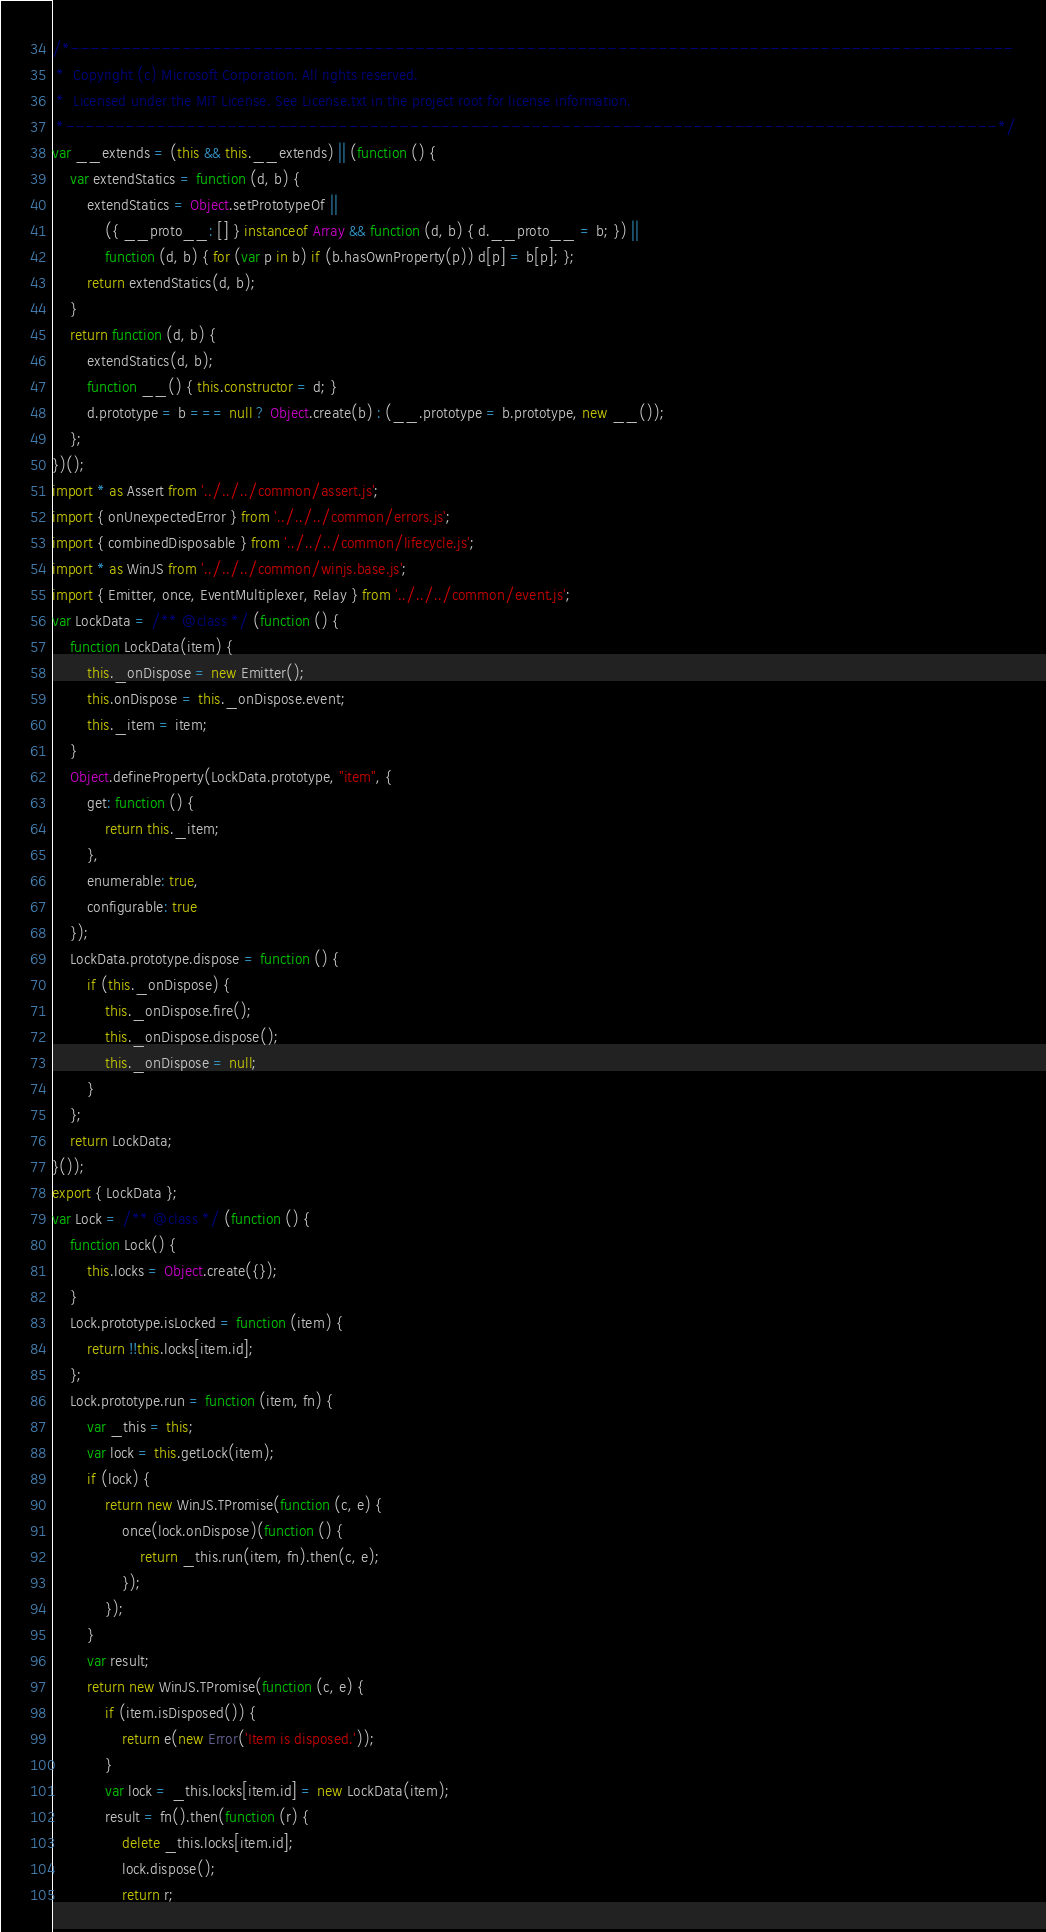<code> <loc_0><loc_0><loc_500><loc_500><_JavaScript_>/*---------------------------------------------------------------------------------------------
 *  Copyright (c) Microsoft Corporation. All rights reserved.
 *  Licensed under the MIT License. See License.txt in the project root for license information.
 *--------------------------------------------------------------------------------------------*/
var __extends = (this && this.__extends) || (function () {
    var extendStatics = function (d, b) {
        extendStatics = Object.setPrototypeOf ||
            ({ __proto__: [] } instanceof Array && function (d, b) { d.__proto__ = b; }) ||
            function (d, b) { for (var p in b) if (b.hasOwnProperty(p)) d[p] = b[p]; };
        return extendStatics(d, b);
    }
    return function (d, b) {
        extendStatics(d, b);
        function __() { this.constructor = d; }
        d.prototype = b === null ? Object.create(b) : (__.prototype = b.prototype, new __());
    };
})();
import * as Assert from '../../../common/assert.js';
import { onUnexpectedError } from '../../../common/errors.js';
import { combinedDisposable } from '../../../common/lifecycle.js';
import * as WinJS from '../../../common/winjs.base.js';
import { Emitter, once, EventMultiplexer, Relay } from '../../../common/event.js';
var LockData = /** @class */ (function () {
    function LockData(item) {
        this._onDispose = new Emitter();
        this.onDispose = this._onDispose.event;
        this._item = item;
    }
    Object.defineProperty(LockData.prototype, "item", {
        get: function () {
            return this._item;
        },
        enumerable: true,
        configurable: true
    });
    LockData.prototype.dispose = function () {
        if (this._onDispose) {
            this._onDispose.fire();
            this._onDispose.dispose();
            this._onDispose = null;
        }
    };
    return LockData;
}());
export { LockData };
var Lock = /** @class */ (function () {
    function Lock() {
        this.locks = Object.create({});
    }
    Lock.prototype.isLocked = function (item) {
        return !!this.locks[item.id];
    };
    Lock.prototype.run = function (item, fn) {
        var _this = this;
        var lock = this.getLock(item);
        if (lock) {
            return new WinJS.TPromise(function (c, e) {
                once(lock.onDispose)(function () {
                    return _this.run(item, fn).then(c, e);
                });
            });
        }
        var result;
        return new WinJS.TPromise(function (c, e) {
            if (item.isDisposed()) {
                return e(new Error('Item is disposed.'));
            }
            var lock = _this.locks[item.id] = new LockData(item);
            result = fn().then(function (r) {
                delete _this.locks[item.id];
                lock.dispose();
                return r;</code> 